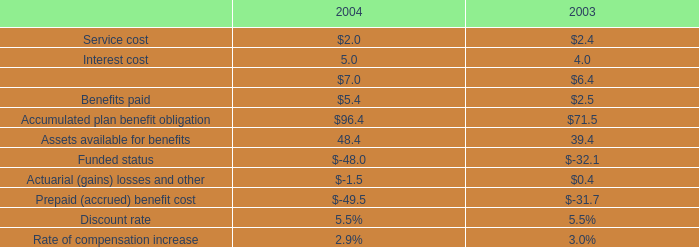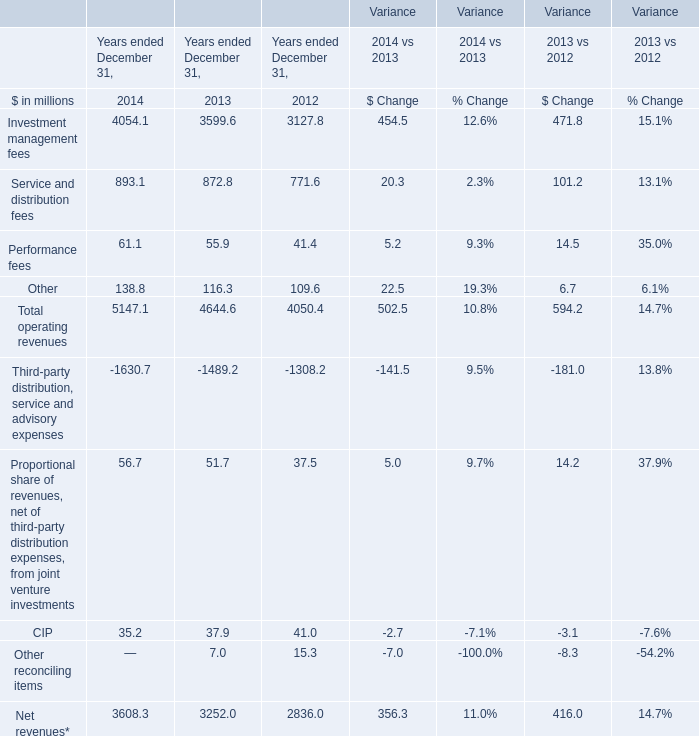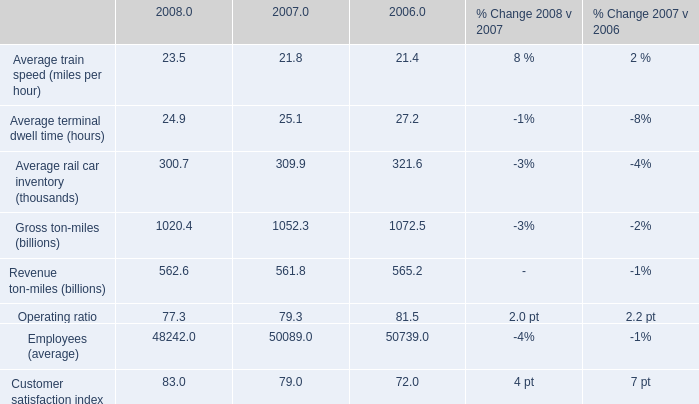based on the operating/performance statistics what was the average operating ratio from 2006 to 2008 
Computations: ((77.3 + 79.3) + 81.5)
Answer: 238.1. 